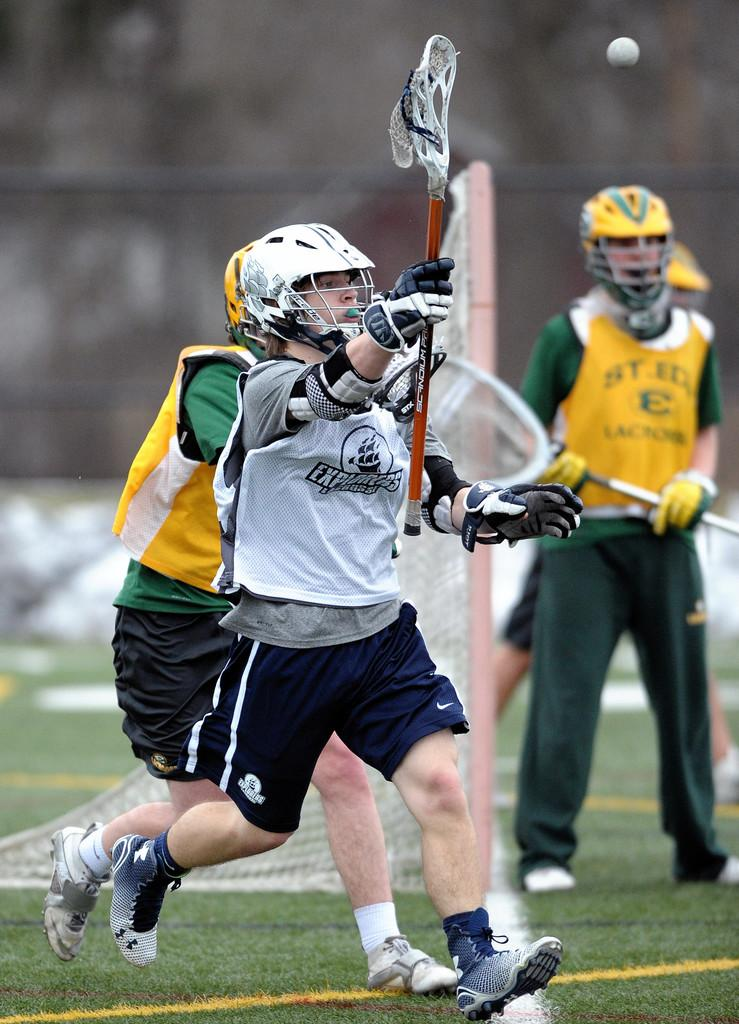How many people are in the image? There are three men in the image. What are the men doing in the image? The men are playing a game. What protective gear are the men wearing? The men are wearing helmets. What type of footwear are the men wearing? The men are wearing shoes. What is the color of the grass at the bottom of the image? The grass at the bottom of the image is green. How would you describe the background of the image? The background of the image is blurred. What type of jewel can be seen in the image? There is no jewel present in the image. What type of grain is being harvested in the background of the image? There is no grain or harvesting activity depicted in the image. 